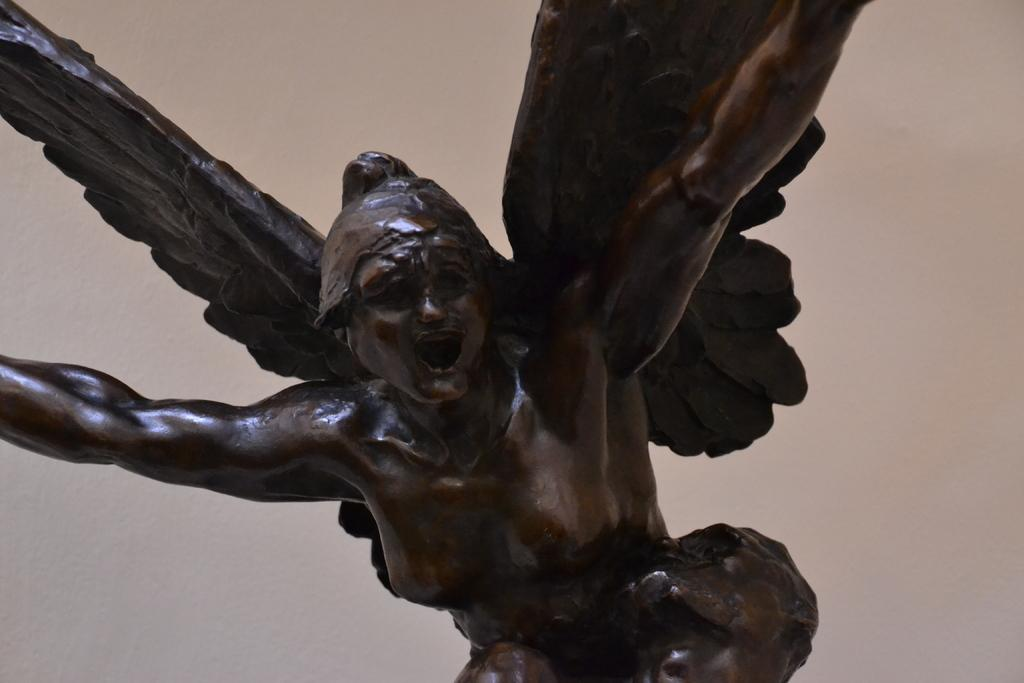What is the main subject of the image? There is a sculpture in the image. Can you describe the background of the image? There is a well in the background of the image. What is the average income of the people living near the sculpture in the image? The image does not provide information about the income of people living near the sculpture, so it cannot be determined from the image. 